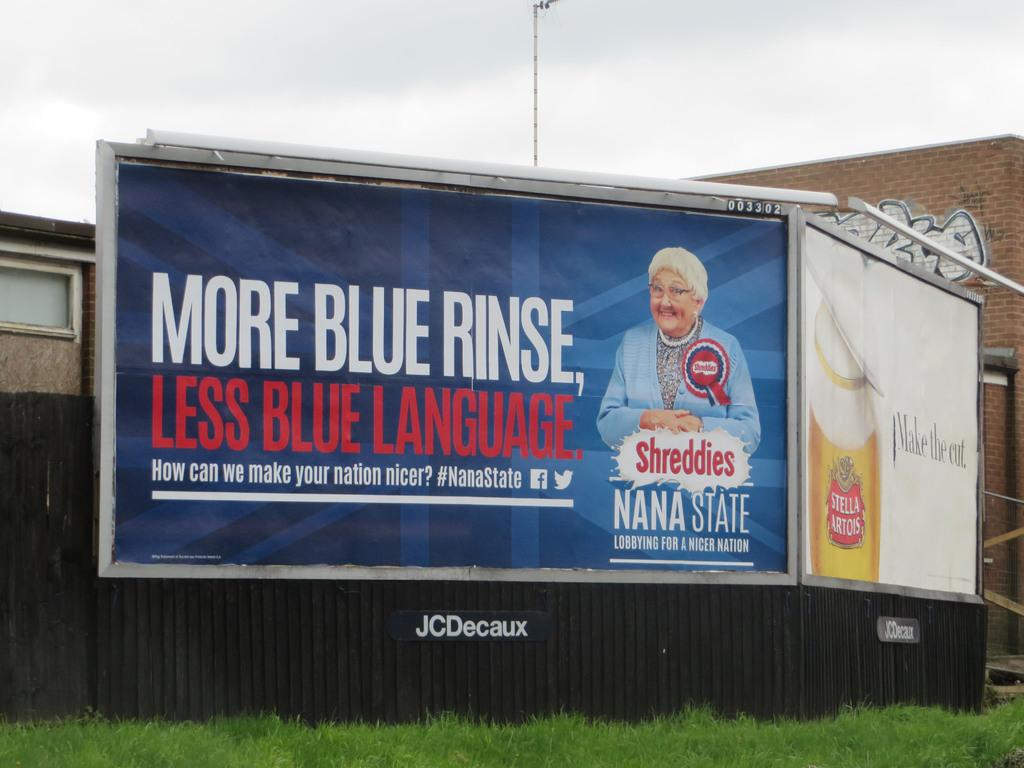<image>
Relay a brief, clear account of the picture shown. the words blue rinse that is on a billboard 